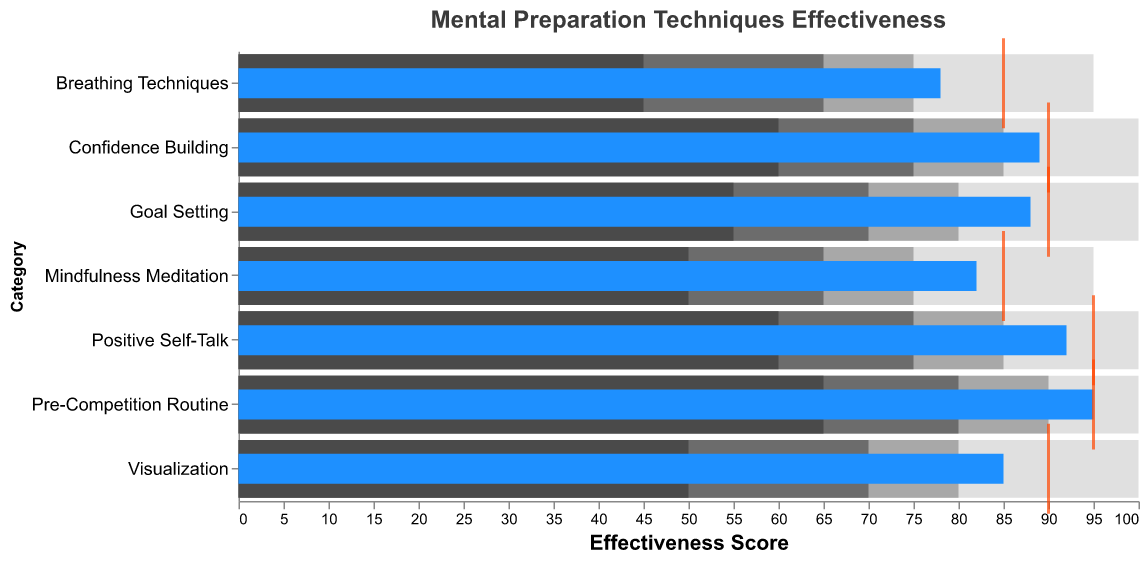What is the title of the chart? The title is located at the top of the chart. It reads "Mental Preparation Techniques Effectiveness".
Answer: Mental Preparation Techniques Effectiveness What's the effectiveness score for Visualization compared to its target? For Visualization, the Actual score (blue bar) is 85 and the Target score (orange tick) is 90. By comparing them, we find that the Actual score is 5 points below the Target score.
Answer: 5 points below Which category has the highest Actual score? The Actual scores are represented by blue bars. The highest blue bar corresponds to "Pre-Competition Routine" with an Actual score of 95.
Answer: Pre-Competition Routine How many categories met or exceeded their target scores? Compare each Actual score (blue bar) with its corresponding Target score (orange tick). Categories that have Actual scores equal to or greater than their Target scores are counted. They are "Pre-Competition Routine".
Answer: 1 Which category has the lowest Actual score, and what is its score? By comparing the length of the blue bars, the shortest one corresponds to "Breathing Techniques" with an Actual score of 78.
Answer: Breathing Techniques, 78 What is the difference between the Actual and Target scores for Confidence Building? The Actual score for Confidence Building is 89, and the Target score is 90. The difference is 90 - 89.
Answer: 1 Which categories have an Actual score within the "Excellent" range? The Excellent range is from Good to Excellent, meaning a score between 90 and 100. By checking the blue bars, "Positive Self-Talk" and "Pre-Competition Routine" fall into this category.
Answer: Positive Self-Talk, Pre-Competition Routine What is the average Target score across all categories? The Target scores are 90, 95, 85, 90, 85, 95, and 90. Adding them up gives 630. There are 7 categories. The average is 630/7.
Answer: 90 How does the effectiveness of Goal Setting compare to Mindfulness Meditation in terms of Actual scores? The Actual score for Goal Setting is 88, while for Mindfulness Meditation, it is 82. Goal Setting scored 6 points higher than Mindfulness Meditation.
Answer: 6 points higher Which category performed the closest to its Target score? Calculate the difference between the Actual and Target scores for each category. The smallest difference is for “Pre-Competition Routine” with a difference of 0 (Actual 95, Target 95).
Answer: Pre-Competition Routine 